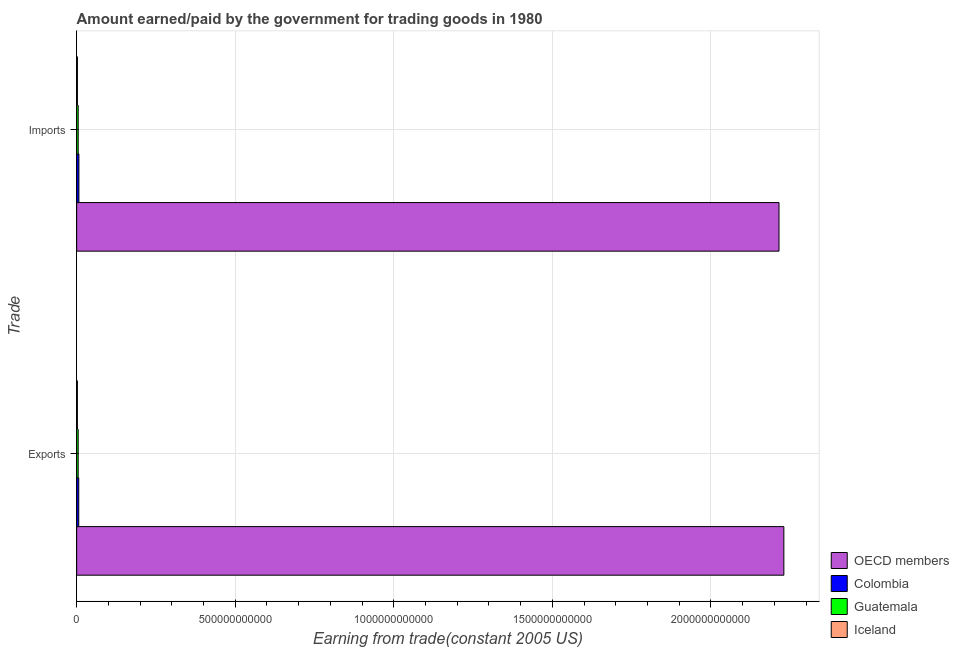How many different coloured bars are there?
Keep it short and to the point. 4. Are the number of bars per tick equal to the number of legend labels?
Your response must be concise. Yes. Are the number of bars on each tick of the Y-axis equal?
Your response must be concise. Yes. What is the label of the 1st group of bars from the top?
Offer a very short reply. Imports. What is the amount paid for imports in Guatemala?
Your answer should be very brief. 4.85e+09. Across all countries, what is the maximum amount earned from exports?
Provide a succinct answer. 2.23e+12. Across all countries, what is the minimum amount earned from exports?
Give a very brief answer. 2.33e+09. In which country was the amount earned from exports minimum?
Offer a terse response. Iceland. What is the total amount earned from exports in the graph?
Ensure brevity in your answer.  2.24e+12. What is the difference between the amount paid for imports in OECD members and that in Guatemala?
Offer a terse response. 2.21e+12. What is the difference between the amount paid for imports in Guatemala and the amount earned from exports in Iceland?
Your response must be concise. 2.52e+09. What is the average amount earned from exports per country?
Your response must be concise. 5.61e+11. What is the difference between the amount earned from exports and amount paid for imports in Colombia?
Your response must be concise. -4.87e+08. In how many countries, is the amount paid for imports greater than 1500000000000 US$?
Ensure brevity in your answer.  1. What is the ratio of the amount paid for imports in OECD members to that in Iceland?
Offer a very short reply. 918.67. What does the 2nd bar from the top in Imports represents?
Ensure brevity in your answer.  Guatemala. How many countries are there in the graph?
Ensure brevity in your answer.  4. What is the difference between two consecutive major ticks on the X-axis?
Your response must be concise. 5.00e+11. Are the values on the major ticks of X-axis written in scientific E-notation?
Your response must be concise. No. Does the graph contain any zero values?
Ensure brevity in your answer.  No. Does the graph contain grids?
Ensure brevity in your answer.  Yes. How many legend labels are there?
Your answer should be compact. 4. What is the title of the graph?
Offer a very short reply. Amount earned/paid by the government for trading goods in 1980. Does "Jamaica" appear as one of the legend labels in the graph?
Your answer should be very brief. No. What is the label or title of the X-axis?
Your response must be concise. Earning from trade(constant 2005 US). What is the label or title of the Y-axis?
Your response must be concise. Trade. What is the Earning from trade(constant 2005 US) of OECD members in Exports?
Make the answer very short. 2.23e+12. What is the Earning from trade(constant 2005 US) of Colombia in Exports?
Provide a succinct answer. 6.61e+09. What is the Earning from trade(constant 2005 US) in Guatemala in Exports?
Provide a succinct answer. 4.81e+09. What is the Earning from trade(constant 2005 US) of Iceland in Exports?
Keep it short and to the point. 2.33e+09. What is the Earning from trade(constant 2005 US) of OECD members in Imports?
Provide a short and direct response. 2.21e+12. What is the Earning from trade(constant 2005 US) of Colombia in Imports?
Your answer should be very brief. 7.10e+09. What is the Earning from trade(constant 2005 US) of Guatemala in Imports?
Offer a very short reply. 4.85e+09. What is the Earning from trade(constant 2005 US) in Iceland in Imports?
Provide a succinct answer. 2.41e+09. Across all Trade, what is the maximum Earning from trade(constant 2005 US) of OECD members?
Offer a very short reply. 2.23e+12. Across all Trade, what is the maximum Earning from trade(constant 2005 US) in Colombia?
Keep it short and to the point. 7.10e+09. Across all Trade, what is the maximum Earning from trade(constant 2005 US) in Guatemala?
Provide a succinct answer. 4.85e+09. Across all Trade, what is the maximum Earning from trade(constant 2005 US) of Iceland?
Give a very brief answer. 2.41e+09. Across all Trade, what is the minimum Earning from trade(constant 2005 US) in OECD members?
Make the answer very short. 2.21e+12. Across all Trade, what is the minimum Earning from trade(constant 2005 US) in Colombia?
Offer a terse response. 6.61e+09. Across all Trade, what is the minimum Earning from trade(constant 2005 US) in Guatemala?
Your response must be concise. 4.81e+09. Across all Trade, what is the minimum Earning from trade(constant 2005 US) in Iceland?
Make the answer very short. 2.33e+09. What is the total Earning from trade(constant 2005 US) in OECD members in the graph?
Offer a terse response. 4.44e+12. What is the total Earning from trade(constant 2005 US) of Colombia in the graph?
Provide a succinct answer. 1.37e+1. What is the total Earning from trade(constant 2005 US) in Guatemala in the graph?
Offer a terse response. 9.65e+09. What is the total Earning from trade(constant 2005 US) in Iceland in the graph?
Ensure brevity in your answer.  4.74e+09. What is the difference between the Earning from trade(constant 2005 US) in OECD members in Exports and that in Imports?
Keep it short and to the point. 1.53e+1. What is the difference between the Earning from trade(constant 2005 US) of Colombia in Exports and that in Imports?
Provide a short and direct response. -4.87e+08. What is the difference between the Earning from trade(constant 2005 US) of Guatemala in Exports and that in Imports?
Offer a terse response. -4.16e+07. What is the difference between the Earning from trade(constant 2005 US) of Iceland in Exports and that in Imports?
Give a very brief answer. -8.19e+07. What is the difference between the Earning from trade(constant 2005 US) in OECD members in Exports and the Earning from trade(constant 2005 US) in Colombia in Imports?
Provide a short and direct response. 2.22e+12. What is the difference between the Earning from trade(constant 2005 US) of OECD members in Exports and the Earning from trade(constant 2005 US) of Guatemala in Imports?
Provide a succinct answer. 2.22e+12. What is the difference between the Earning from trade(constant 2005 US) of OECD members in Exports and the Earning from trade(constant 2005 US) of Iceland in Imports?
Ensure brevity in your answer.  2.23e+12. What is the difference between the Earning from trade(constant 2005 US) of Colombia in Exports and the Earning from trade(constant 2005 US) of Guatemala in Imports?
Offer a terse response. 1.76e+09. What is the difference between the Earning from trade(constant 2005 US) in Colombia in Exports and the Earning from trade(constant 2005 US) in Iceland in Imports?
Ensure brevity in your answer.  4.20e+09. What is the difference between the Earning from trade(constant 2005 US) in Guatemala in Exports and the Earning from trade(constant 2005 US) in Iceland in Imports?
Your answer should be compact. 2.40e+09. What is the average Earning from trade(constant 2005 US) of OECD members per Trade?
Give a very brief answer. 2.22e+12. What is the average Earning from trade(constant 2005 US) of Colombia per Trade?
Give a very brief answer. 6.85e+09. What is the average Earning from trade(constant 2005 US) of Guatemala per Trade?
Provide a short and direct response. 4.83e+09. What is the average Earning from trade(constant 2005 US) in Iceland per Trade?
Give a very brief answer. 2.37e+09. What is the difference between the Earning from trade(constant 2005 US) in OECD members and Earning from trade(constant 2005 US) in Colombia in Exports?
Keep it short and to the point. 2.22e+12. What is the difference between the Earning from trade(constant 2005 US) of OECD members and Earning from trade(constant 2005 US) of Guatemala in Exports?
Give a very brief answer. 2.23e+12. What is the difference between the Earning from trade(constant 2005 US) in OECD members and Earning from trade(constant 2005 US) in Iceland in Exports?
Provide a short and direct response. 2.23e+12. What is the difference between the Earning from trade(constant 2005 US) of Colombia and Earning from trade(constant 2005 US) of Guatemala in Exports?
Provide a short and direct response. 1.80e+09. What is the difference between the Earning from trade(constant 2005 US) of Colombia and Earning from trade(constant 2005 US) of Iceland in Exports?
Your response must be concise. 4.28e+09. What is the difference between the Earning from trade(constant 2005 US) of Guatemala and Earning from trade(constant 2005 US) of Iceland in Exports?
Your answer should be very brief. 2.48e+09. What is the difference between the Earning from trade(constant 2005 US) of OECD members and Earning from trade(constant 2005 US) of Colombia in Imports?
Your answer should be compact. 2.21e+12. What is the difference between the Earning from trade(constant 2005 US) in OECD members and Earning from trade(constant 2005 US) in Guatemala in Imports?
Keep it short and to the point. 2.21e+12. What is the difference between the Earning from trade(constant 2005 US) in OECD members and Earning from trade(constant 2005 US) in Iceland in Imports?
Provide a short and direct response. 2.21e+12. What is the difference between the Earning from trade(constant 2005 US) of Colombia and Earning from trade(constant 2005 US) of Guatemala in Imports?
Offer a very short reply. 2.25e+09. What is the difference between the Earning from trade(constant 2005 US) in Colombia and Earning from trade(constant 2005 US) in Iceland in Imports?
Provide a short and direct response. 4.69e+09. What is the difference between the Earning from trade(constant 2005 US) of Guatemala and Earning from trade(constant 2005 US) of Iceland in Imports?
Ensure brevity in your answer.  2.44e+09. What is the ratio of the Earning from trade(constant 2005 US) of Colombia in Exports to that in Imports?
Provide a succinct answer. 0.93. What is the ratio of the Earning from trade(constant 2005 US) in Guatemala in Exports to that in Imports?
Your answer should be compact. 0.99. What is the ratio of the Earning from trade(constant 2005 US) of Iceland in Exports to that in Imports?
Provide a short and direct response. 0.97. What is the difference between the highest and the second highest Earning from trade(constant 2005 US) in OECD members?
Give a very brief answer. 1.53e+1. What is the difference between the highest and the second highest Earning from trade(constant 2005 US) in Colombia?
Offer a terse response. 4.87e+08. What is the difference between the highest and the second highest Earning from trade(constant 2005 US) in Guatemala?
Your answer should be compact. 4.16e+07. What is the difference between the highest and the second highest Earning from trade(constant 2005 US) of Iceland?
Provide a succinct answer. 8.19e+07. What is the difference between the highest and the lowest Earning from trade(constant 2005 US) of OECD members?
Provide a short and direct response. 1.53e+1. What is the difference between the highest and the lowest Earning from trade(constant 2005 US) in Colombia?
Your answer should be very brief. 4.87e+08. What is the difference between the highest and the lowest Earning from trade(constant 2005 US) in Guatemala?
Provide a short and direct response. 4.16e+07. What is the difference between the highest and the lowest Earning from trade(constant 2005 US) of Iceland?
Make the answer very short. 8.19e+07. 